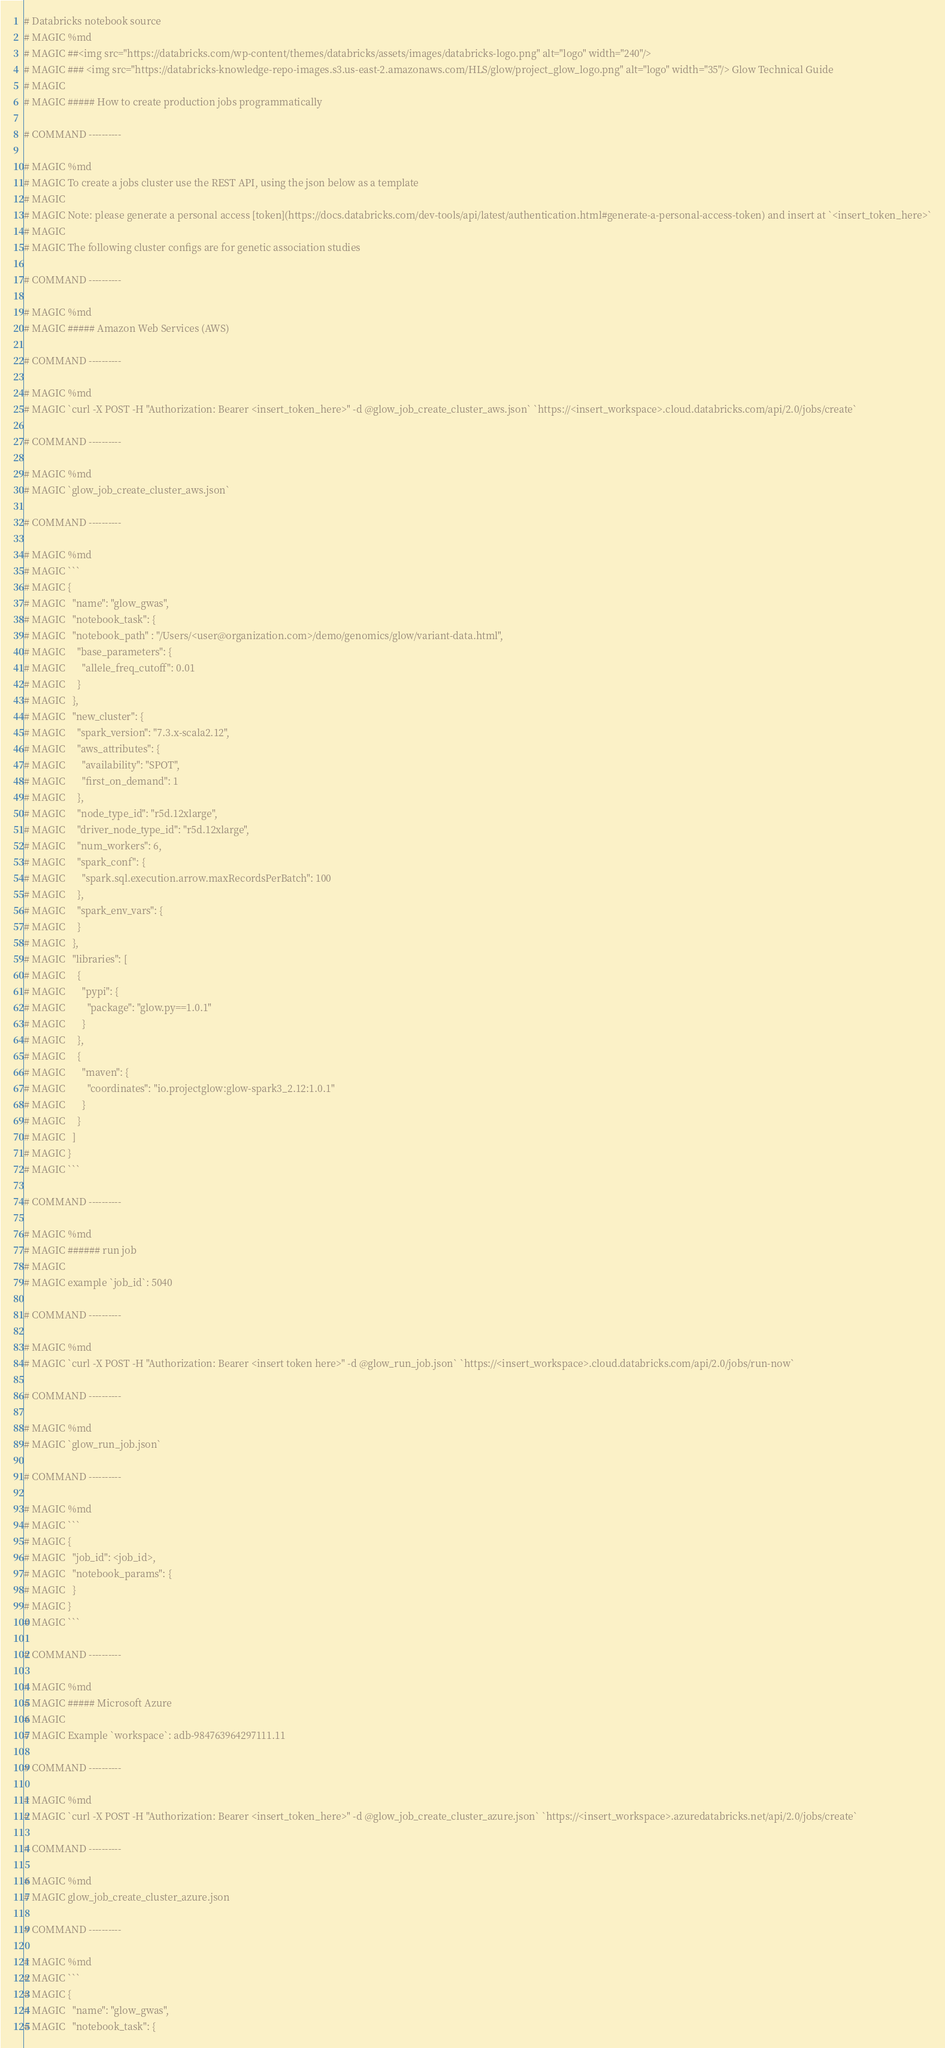Convert code to text. <code><loc_0><loc_0><loc_500><loc_500><_Python_># Databricks notebook source
# MAGIC %md
# MAGIC ##<img src="https://databricks.com/wp-content/themes/databricks/assets/images/databricks-logo.png" alt="logo" width="240"/> 
# MAGIC ### <img src="https://databricks-knowledge-repo-images.s3.us-east-2.amazonaws.com/HLS/glow/project_glow_logo.png" alt="logo" width="35"/> Glow Technical Guide
# MAGIC 
# MAGIC ##### How to create production jobs programmatically

# COMMAND ----------

# MAGIC %md
# MAGIC To create a jobs cluster use the REST API, using the json below as a template
# MAGIC 
# MAGIC Note: please generate a personal access [token](https://docs.databricks.com/dev-tools/api/latest/authentication.html#generate-a-personal-access-token) and insert at `<insert_token_here>`
# MAGIC 
# MAGIC The following cluster configs are for genetic association studies

# COMMAND ----------

# MAGIC %md
# MAGIC ##### Amazon Web Services (AWS)

# COMMAND ----------

# MAGIC %md
# MAGIC `curl -X POST -H "Authorization: Bearer <insert_token_here>" -d @glow_job_create_cluster_aws.json` `https://<insert_workspace>.cloud.databricks.com/api/2.0/jobs/create`

# COMMAND ----------

# MAGIC %md
# MAGIC `glow_job_create_cluster_aws.json`

# COMMAND ----------

# MAGIC %md
# MAGIC ```
# MAGIC {
# MAGIC   "name": "glow_gwas",
# MAGIC   "notebook_task": {
# MAGIC   "notebook_path" : "/Users/<user@organization.com>/demo/genomics/glow/variant-data.html",
# MAGIC     "base_parameters": {
# MAGIC       "allele_freq_cutoff": 0.01
# MAGIC     }
# MAGIC   },
# MAGIC   "new_cluster": {
# MAGIC     "spark_version": "7.3.x-scala2.12",
# MAGIC     "aws_attributes": {
# MAGIC       "availability": "SPOT",
# MAGIC       "first_on_demand": 1
# MAGIC     },
# MAGIC     "node_type_id": "r5d.12xlarge",
# MAGIC     "driver_node_type_id": "r5d.12xlarge",
# MAGIC     "num_workers": 6,
# MAGIC     "spark_conf": {
# MAGIC       "spark.sql.execution.arrow.maxRecordsPerBatch": 100
# MAGIC     },
# MAGIC     "spark_env_vars": {
# MAGIC     }
# MAGIC   },
# MAGIC   "libraries": [
# MAGIC     {
# MAGIC       "pypi": {
# MAGIC         "package": "glow.py==1.0.1"
# MAGIC       }
# MAGIC     },
# MAGIC     {
# MAGIC       "maven": {
# MAGIC         "coordinates": "io.projectglow:glow-spark3_2.12:1.0.1"
# MAGIC       }
# MAGIC     }
# MAGIC   ]
# MAGIC }
# MAGIC ```

# COMMAND ----------

# MAGIC %md
# MAGIC ###### run job
# MAGIC 
# MAGIC example `job_id`: 5040

# COMMAND ----------

# MAGIC %md
# MAGIC `curl -X POST -H "Authorization: Bearer <insert token here>" -d @glow_run_job.json` `https://<insert_workspace>.cloud.databricks.com/api/2.0/jobs/run-now`

# COMMAND ----------

# MAGIC %md
# MAGIC `glow_run_job.json`

# COMMAND ----------

# MAGIC %md
# MAGIC ```
# MAGIC {
# MAGIC   "job_id": <job_id>,
# MAGIC   "notebook_params": {
# MAGIC   }
# MAGIC }
# MAGIC ```

# COMMAND ----------

# MAGIC %md
# MAGIC ##### Microsoft Azure
# MAGIC 
# MAGIC Example `workspace`: adb-984763964297111.11

# COMMAND ----------

# MAGIC %md
# MAGIC `curl -X POST -H "Authorization: Bearer <insert_token_here>" -d @glow_job_create_cluster_azure.json` `https://<insert_workspace>.azuredatabricks.net/api/2.0/jobs/create`

# COMMAND ----------

# MAGIC %md
# MAGIC glow_job_create_cluster_azure.json

# COMMAND ----------

# MAGIC %md
# MAGIC ```
# MAGIC {
# MAGIC   "name": "glow_gwas",
# MAGIC   "notebook_task": {</code> 